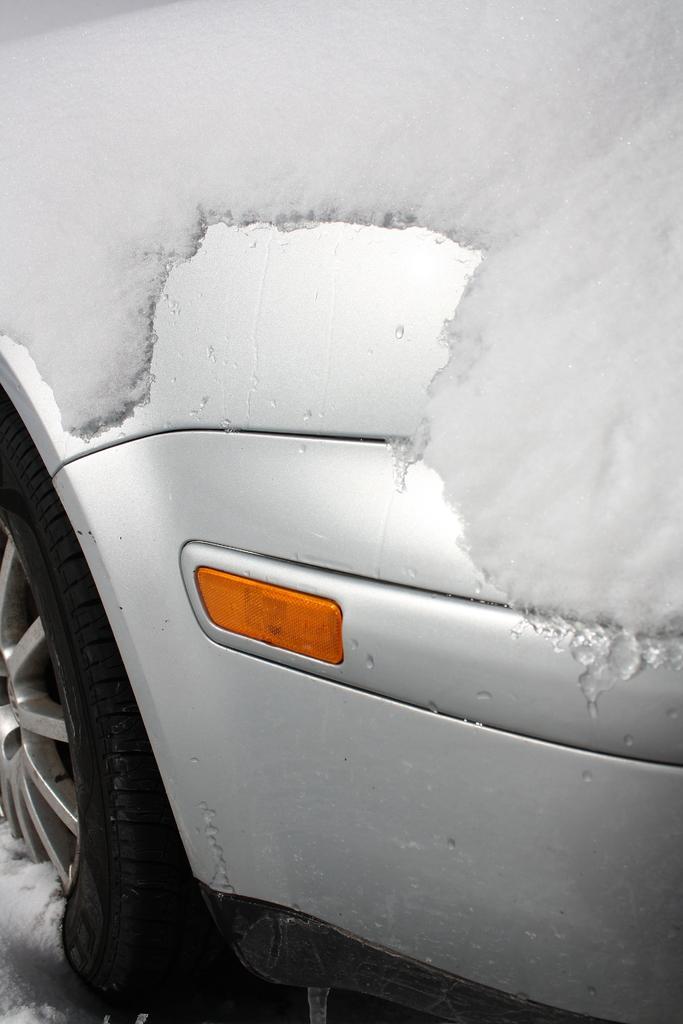Can you describe this image briefly? In this image we can see a part of a car covered with snow. 